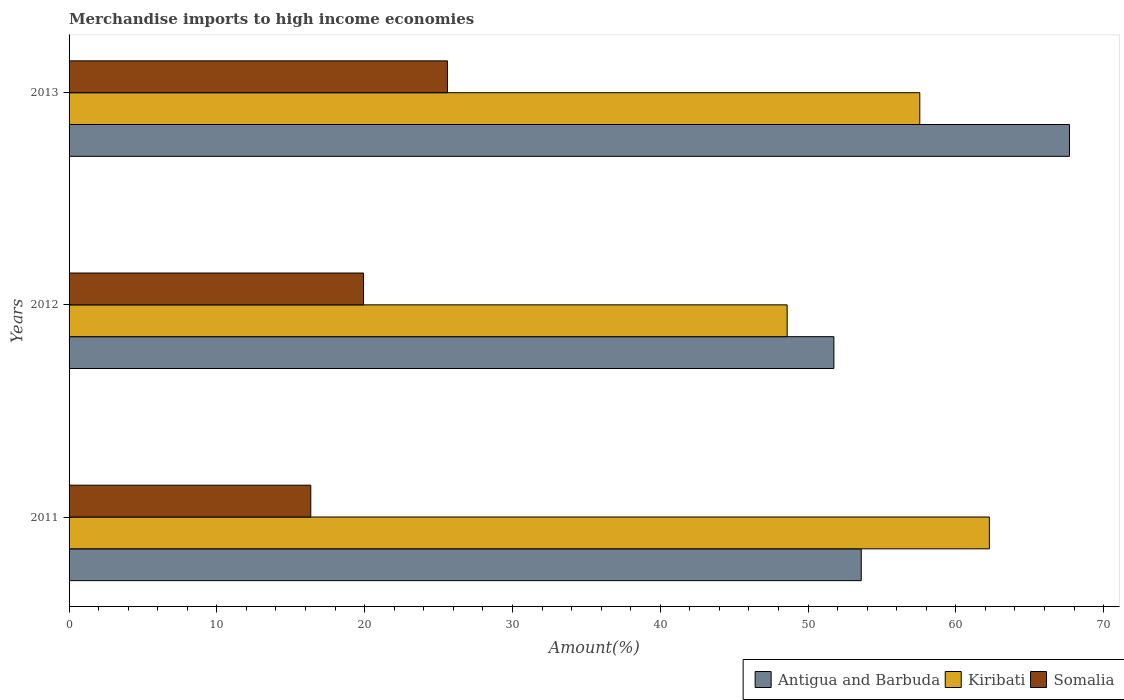How many different coloured bars are there?
Your answer should be compact. 3. How many groups of bars are there?
Give a very brief answer. 3. Are the number of bars on each tick of the Y-axis equal?
Your response must be concise. Yes. How many bars are there on the 1st tick from the top?
Provide a short and direct response. 3. How many bars are there on the 1st tick from the bottom?
Offer a terse response. 3. What is the percentage of amount earned from merchandise imports in Somalia in 2011?
Offer a terse response. 16.35. Across all years, what is the maximum percentage of amount earned from merchandise imports in Somalia?
Offer a terse response. 25.6. Across all years, what is the minimum percentage of amount earned from merchandise imports in Kiribati?
Ensure brevity in your answer.  48.59. In which year was the percentage of amount earned from merchandise imports in Antigua and Barbuda minimum?
Your response must be concise. 2012. What is the total percentage of amount earned from merchandise imports in Kiribati in the graph?
Offer a terse response. 168.42. What is the difference between the percentage of amount earned from merchandise imports in Somalia in 2012 and that in 2013?
Offer a terse response. -5.68. What is the difference between the percentage of amount earned from merchandise imports in Kiribati in 2011 and the percentage of amount earned from merchandise imports in Somalia in 2013?
Your answer should be very brief. 36.67. What is the average percentage of amount earned from merchandise imports in Kiribati per year?
Provide a succinct answer. 56.14. In the year 2013, what is the difference between the percentage of amount earned from merchandise imports in Kiribati and percentage of amount earned from merchandise imports in Somalia?
Provide a short and direct response. 31.96. What is the ratio of the percentage of amount earned from merchandise imports in Kiribati in 2012 to that in 2013?
Keep it short and to the point. 0.84. What is the difference between the highest and the second highest percentage of amount earned from merchandise imports in Somalia?
Provide a short and direct response. 5.68. What is the difference between the highest and the lowest percentage of amount earned from merchandise imports in Somalia?
Provide a short and direct response. 9.25. In how many years, is the percentage of amount earned from merchandise imports in Kiribati greater than the average percentage of amount earned from merchandise imports in Kiribati taken over all years?
Offer a terse response. 2. What does the 2nd bar from the top in 2012 represents?
Offer a terse response. Kiribati. What does the 1st bar from the bottom in 2011 represents?
Make the answer very short. Antigua and Barbuda. Is it the case that in every year, the sum of the percentage of amount earned from merchandise imports in Somalia and percentage of amount earned from merchandise imports in Kiribati is greater than the percentage of amount earned from merchandise imports in Antigua and Barbuda?
Your answer should be compact. Yes. Are all the bars in the graph horizontal?
Keep it short and to the point. Yes. How many years are there in the graph?
Your response must be concise. 3. Does the graph contain any zero values?
Provide a short and direct response. No. Where does the legend appear in the graph?
Give a very brief answer. Bottom right. What is the title of the graph?
Ensure brevity in your answer.  Merchandise imports to high income economies. Does "Nicaragua" appear as one of the legend labels in the graph?
Offer a very short reply. No. What is the label or title of the X-axis?
Make the answer very short. Amount(%). What is the Amount(%) in Antigua and Barbuda in 2011?
Your answer should be compact. 53.6. What is the Amount(%) in Kiribati in 2011?
Provide a succinct answer. 62.27. What is the Amount(%) of Somalia in 2011?
Keep it short and to the point. 16.35. What is the Amount(%) in Antigua and Barbuda in 2012?
Ensure brevity in your answer.  51.75. What is the Amount(%) in Kiribati in 2012?
Provide a succinct answer. 48.59. What is the Amount(%) of Somalia in 2012?
Ensure brevity in your answer.  19.92. What is the Amount(%) of Antigua and Barbuda in 2013?
Keep it short and to the point. 67.69. What is the Amount(%) of Kiribati in 2013?
Your answer should be very brief. 57.56. What is the Amount(%) of Somalia in 2013?
Make the answer very short. 25.6. Across all years, what is the maximum Amount(%) of Antigua and Barbuda?
Make the answer very short. 67.69. Across all years, what is the maximum Amount(%) in Kiribati?
Offer a terse response. 62.27. Across all years, what is the maximum Amount(%) in Somalia?
Provide a short and direct response. 25.6. Across all years, what is the minimum Amount(%) of Antigua and Barbuda?
Make the answer very short. 51.75. Across all years, what is the minimum Amount(%) in Kiribati?
Your answer should be very brief. 48.59. Across all years, what is the minimum Amount(%) in Somalia?
Offer a terse response. 16.35. What is the total Amount(%) in Antigua and Barbuda in the graph?
Your answer should be very brief. 173.04. What is the total Amount(%) in Kiribati in the graph?
Provide a short and direct response. 168.42. What is the total Amount(%) of Somalia in the graph?
Provide a succinct answer. 61.88. What is the difference between the Amount(%) of Antigua and Barbuda in 2011 and that in 2012?
Your response must be concise. 1.85. What is the difference between the Amount(%) in Kiribati in 2011 and that in 2012?
Give a very brief answer. 13.69. What is the difference between the Amount(%) in Somalia in 2011 and that in 2012?
Your answer should be very brief. -3.57. What is the difference between the Amount(%) of Antigua and Barbuda in 2011 and that in 2013?
Provide a short and direct response. -14.09. What is the difference between the Amount(%) in Kiribati in 2011 and that in 2013?
Give a very brief answer. 4.71. What is the difference between the Amount(%) in Somalia in 2011 and that in 2013?
Ensure brevity in your answer.  -9.25. What is the difference between the Amount(%) in Antigua and Barbuda in 2012 and that in 2013?
Provide a succinct answer. -15.94. What is the difference between the Amount(%) of Kiribati in 2012 and that in 2013?
Keep it short and to the point. -8.98. What is the difference between the Amount(%) of Somalia in 2012 and that in 2013?
Provide a short and direct response. -5.68. What is the difference between the Amount(%) of Antigua and Barbuda in 2011 and the Amount(%) of Kiribati in 2012?
Your answer should be very brief. 5.01. What is the difference between the Amount(%) of Antigua and Barbuda in 2011 and the Amount(%) of Somalia in 2012?
Your answer should be compact. 33.68. What is the difference between the Amount(%) of Kiribati in 2011 and the Amount(%) of Somalia in 2012?
Offer a very short reply. 42.35. What is the difference between the Amount(%) in Antigua and Barbuda in 2011 and the Amount(%) in Kiribati in 2013?
Ensure brevity in your answer.  -3.96. What is the difference between the Amount(%) of Antigua and Barbuda in 2011 and the Amount(%) of Somalia in 2013?
Give a very brief answer. 28. What is the difference between the Amount(%) in Kiribati in 2011 and the Amount(%) in Somalia in 2013?
Provide a succinct answer. 36.67. What is the difference between the Amount(%) of Antigua and Barbuda in 2012 and the Amount(%) of Kiribati in 2013?
Ensure brevity in your answer.  -5.81. What is the difference between the Amount(%) of Antigua and Barbuda in 2012 and the Amount(%) of Somalia in 2013?
Give a very brief answer. 26.15. What is the difference between the Amount(%) in Kiribati in 2012 and the Amount(%) in Somalia in 2013?
Ensure brevity in your answer.  22.98. What is the average Amount(%) of Antigua and Barbuda per year?
Give a very brief answer. 57.68. What is the average Amount(%) in Kiribati per year?
Give a very brief answer. 56.14. What is the average Amount(%) of Somalia per year?
Offer a terse response. 20.63. In the year 2011, what is the difference between the Amount(%) in Antigua and Barbuda and Amount(%) in Kiribati?
Keep it short and to the point. -8.67. In the year 2011, what is the difference between the Amount(%) in Antigua and Barbuda and Amount(%) in Somalia?
Your answer should be compact. 37.25. In the year 2011, what is the difference between the Amount(%) in Kiribati and Amount(%) in Somalia?
Keep it short and to the point. 45.92. In the year 2012, what is the difference between the Amount(%) in Antigua and Barbuda and Amount(%) in Kiribati?
Ensure brevity in your answer.  3.16. In the year 2012, what is the difference between the Amount(%) in Antigua and Barbuda and Amount(%) in Somalia?
Offer a terse response. 31.83. In the year 2012, what is the difference between the Amount(%) in Kiribati and Amount(%) in Somalia?
Keep it short and to the point. 28.66. In the year 2013, what is the difference between the Amount(%) in Antigua and Barbuda and Amount(%) in Kiribati?
Provide a short and direct response. 10.13. In the year 2013, what is the difference between the Amount(%) of Antigua and Barbuda and Amount(%) of Somalia?
Ensure brevity in your answer.  42.09. In the year 2013, what is the difference between the Amount(%) in Kiribati and Amount(%) in Somalia?
Give a very brief answer. 31.96. What is the ratio of the Amount(%) in Antigua and Barbuda in 2011 to that in 2012?
Offer a very short reply. 1.04. What is the ratio of the Amount(%) in Kiribati in 2011 to that in 2012?
Keep it short and to the point. 1.28. What is the ratio of the Amount(%) of Somalia in 2011 to that in 2012?
Provide a short and direct response. 0.82. What is the ratio of the Amount(%) of Antigua and Barbuda in 2011 to that in 2013?
Provide a succinct answer. 0.79. What is the ratio of the Amount(%) of Kiribati in 2011 to that in 2013?
Your answer should be compact. 1.08. What is the ratio of the Amount(%) in Somalia in 2011 to that in 2013?
Your answer should be compact. 0.64. What is the ratio of the Amount(%) of Antigua and Barbuda in 2012 to that in 2013?
Keep it short and to the point. 0.76. What is the ratio of the Amount(%) in Kiribati in 2012 to that in 2013?
Offer a terse response. 0.84. What is the ratio of the Amount(%) of Somalia in 2012 to that in 2013?
Offer a very short reply. 0.78. What is the difference between the highest and the second highest Amount(%) in Antigua and Barbuda?
Your answer should be very brief. 14.09. What is the difference between the highest and the second highest Amount(%) in Kiribati?
Give a very brief answer. 4.71. What is the difference between the highest and the second highest Amount(%) in Somalia?
Provide a short and direct response. 5.68. What is the difference between the highest and the lowest Amount(%) of Antigua and Barbuda?
Offer a terse response. 15.94. What is the difference between the highest and the lowest Amount(%) in Kiribati?
Your response must be concise. 13.69. What is the difference between the highest and the lowest Amount(%) of Somalia?
Your response must be concise. 9.25. 